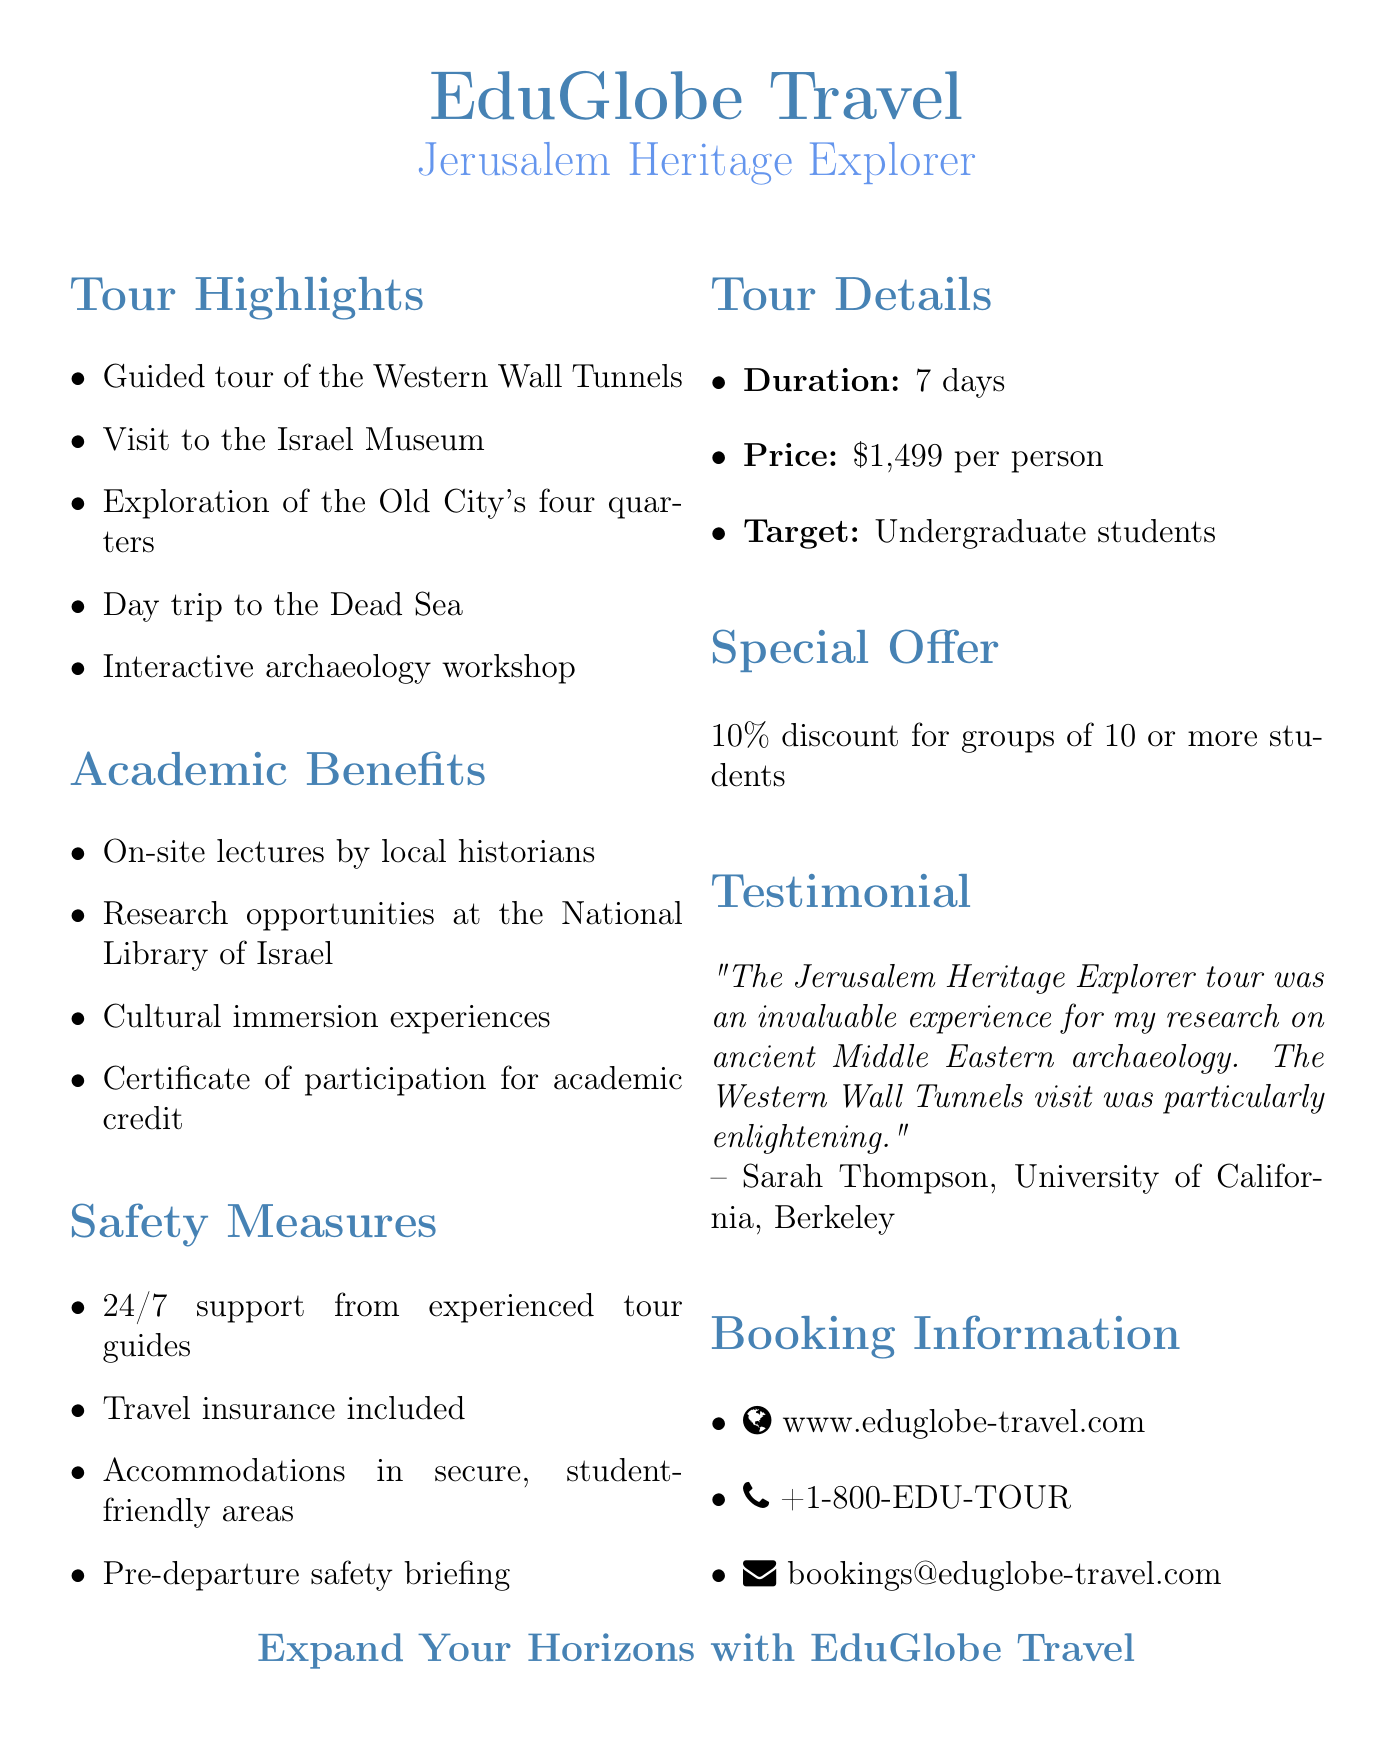What is the agency name? The agency name is explicitly stated in the document as "EduGlobe Travel."
Answer: EduGlobe Travel What is the duration of the tour? The duration of the tour is listed in the tour details section as "7 days."
Answer: 7 days What academic benefit includes local historians? The academic benefits section mentions "On-site lectures by local historians."
Answer: On-site lectures by local historians What safety measure is included during travel? The safety measures section indicates that "Travel insurance included" is one of the measures.
Answer: Travel insurance included How much is the tour price per person? The tour price is clearly stated as "$1,499 per person."
Answer: $1,499 per person What is the special offer for groups? The document lists a special offer as "10% discount for groups of 10 or more students."
Answer: 10% discount for groups of 10 or more students Which city does the tour focus on? The title and content of the document focus on the tour to Jerusalem.
Answer: Jerusalem Who provided the testimonial? The testimonial section names "Sarah Thompson" as the person providing the quote.
Answer: Sarah Thompson 